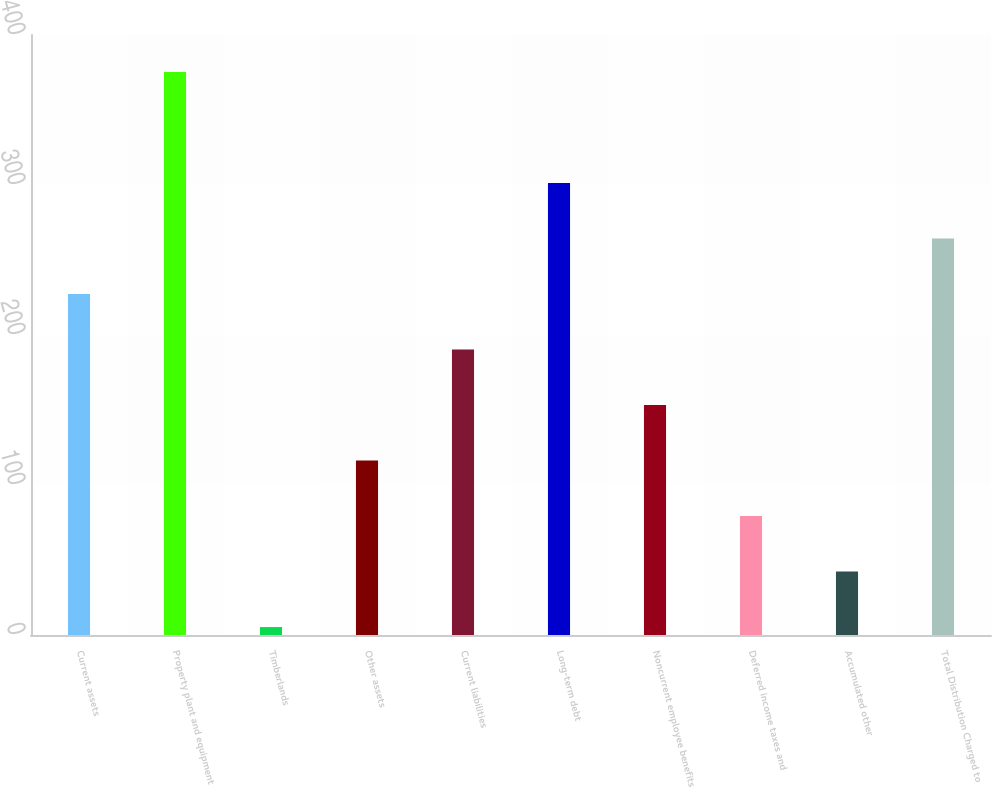<chart> <loc_0><loc_0><loc_500><loc_500><bar_chart><fcel>Current assets<fcel>Property plant and equipment<fcel>Timberlands<fcel>Other assets<fcel>Current liabilities<fcel>Long-term debt<fcel>Noncurrent employee benefits<fcel>Deferred income taxes and<fcel>Accumulated other<fcel>Total Distribution Charged to<nl><fcel>227.36<fcel>375.4<fcel>5.3<fcel>116.33<fcel>190.35<fcel>301.38<fcel>153.34<fcel>79.32<fcel>42.31<fcel>264.37<nl></chart> 